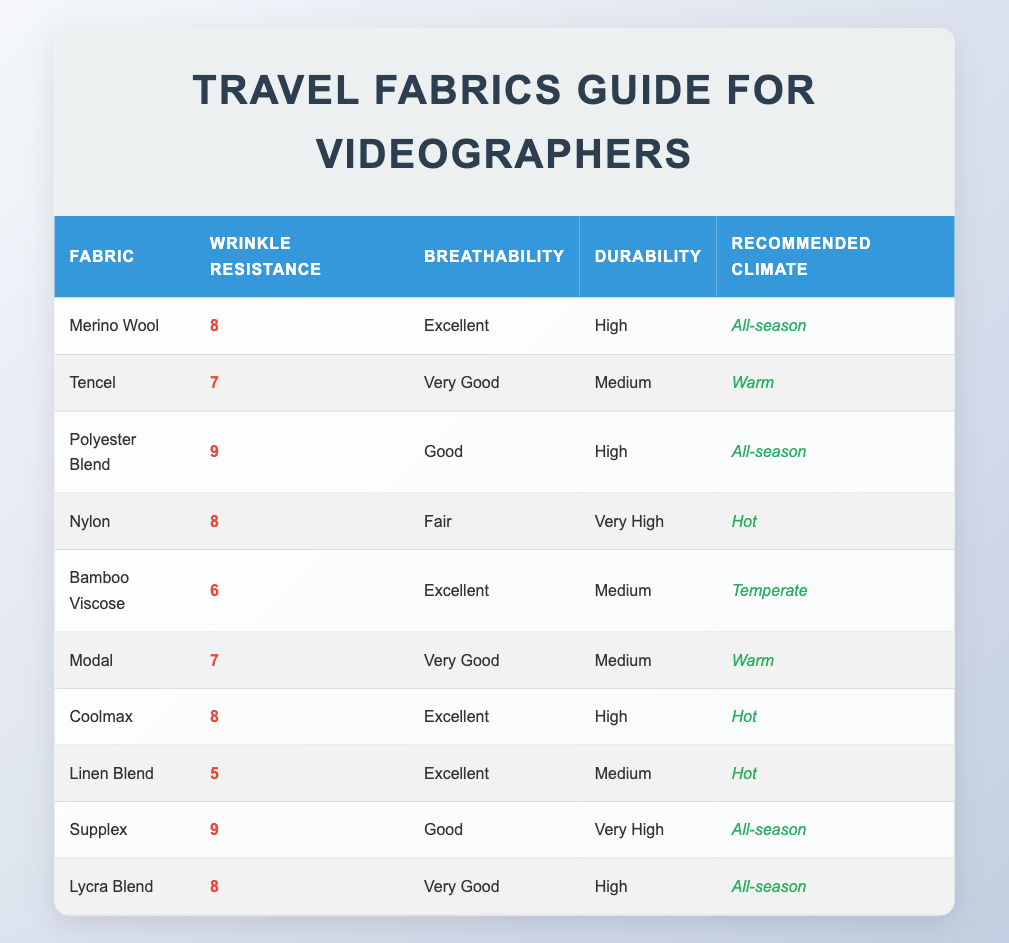What is the wrinkle resistance rating of Merino Wool? The wrinkle resistance rating for Merino Wool is directly listed in the table as 8.
Answer: 8 Which fabric has the highest wrinkle resistance rating? By comparing the wrinkle resistance ratings in the table, Polyester Blend and Supplex both have the highest rating of 9.
Answer: Polyester Blend and Supplex How many fabrics are rated with a wrinkle resistance rating of 7? The fabrics rated with 7 are Tencel, Modal, and there are a total of 3 fabrics.
Answer: 3 Is Bamboo Viscose rated as "Excellent" in breathability? The table indicates that Bamboo Viscose has a breathability rating of "Excellent."
Answer: Yes Which fabric is recommended for warm climates and has a wrinkle resistance rating of 7? The table shows Tencel and Modal as fabrics recommended for warm climates and both have a wrinkle resistance rating of 7.
Answer: Tencel and Modal What is the average wrinkle resistance rating of the fabrics listed? To find the average, we add the ratings: 8 + 7 + 9 + 8 + 6 + 7 + 8 + 5 + 9 + 8 = 75. There are 10 fabrics, so the average is 75/10 = 7.5.
Answer: 7.5 Is there any fabric that has both very high durability and good breathability? Checking the table, the fabric with very high durability is Nylon and Supplex; however, only Supplex is listed with good breathability. Thus, there's no fabric that meets both criteria.
Answer: No Which fabric is suitable for hot climates with a wrinkle resistance rating of 6 or higher? The table lists Nylon, Coolmax, and Supplex as fabrics suitable for hot climates, all having ratings of 6 or higher (Nylon 8, Coolmax 8, Supplex 9).
Answer: Nylon, Coolmax, Supplex 